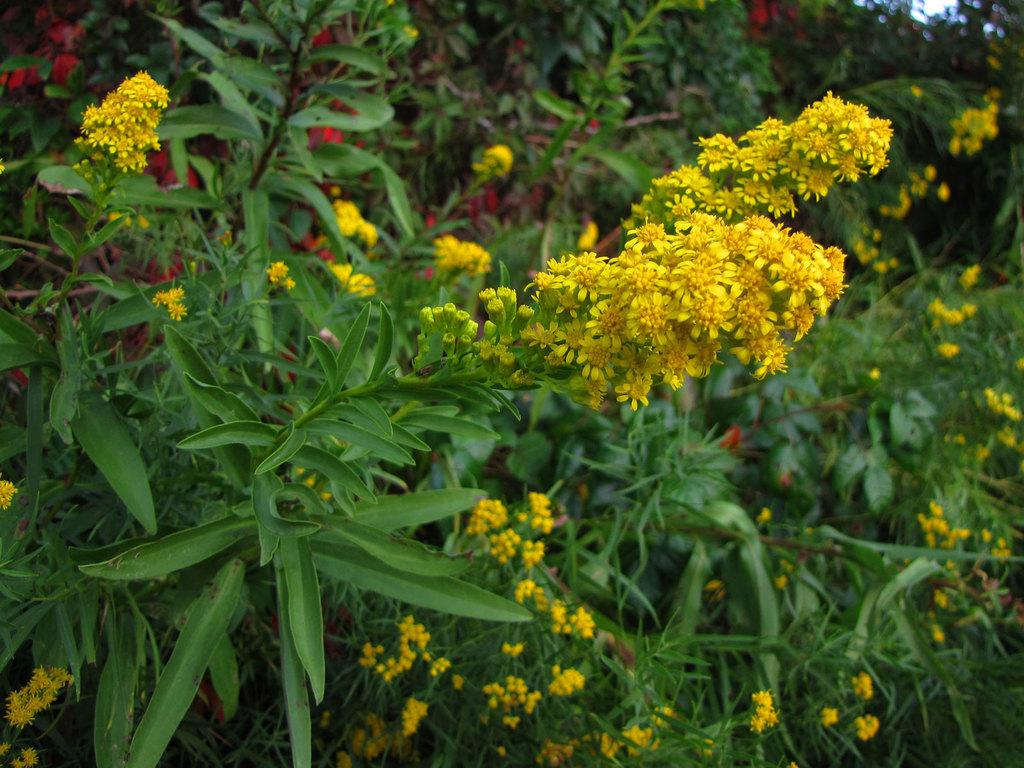What type of living organisms can be seen in the image? Plants and flowers can be seen in the image. What type of vegetation is present in the image? There is grass in the image. What type of knowledge can be gained from the rose in the image? There is no rose present in the image, so no specific knowledge can be gained from it. 